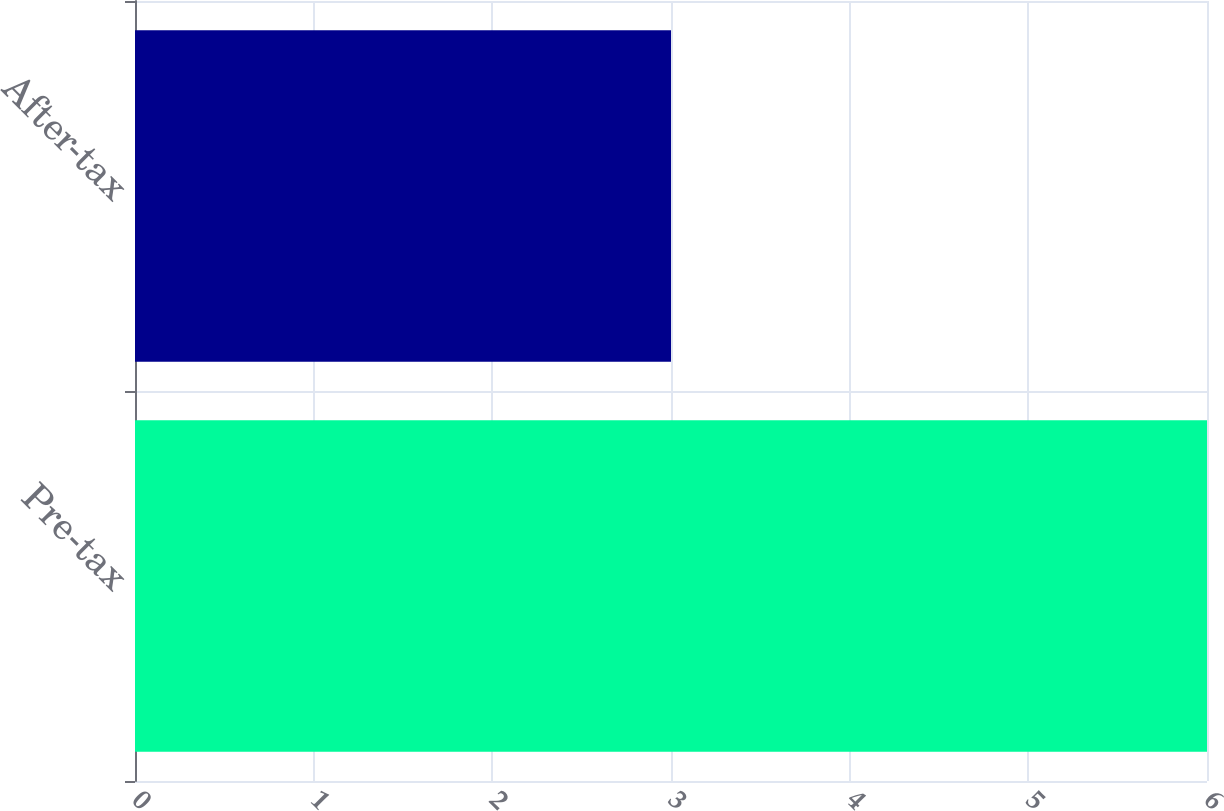Convert chart to OTSL. <chart><loc_0><loc_0><loc_500><loc_500><bar_chart><fcel>Pre-tax<fcel>After-tax<nl><fcel>6<fcel>3<nl></chart> 